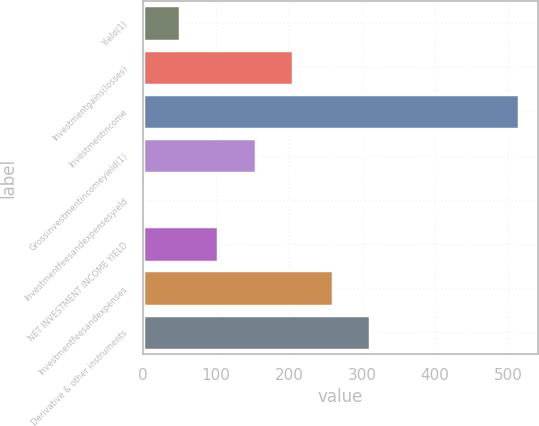Convert chart to OTSL. <chart><loc_0><loc_0><loc_500><loc_500><bar_chart><fcel>Yield(1)<fcel>Investmentgains(losses)<fcel>Investmentincome<fcel>Grossinvestmentincomeyield(1)<fcel>Investmentfeesandexpensesyield<fcel>NET INVESTMENT INCOME YIELD<fcel>Investmentfeesandexpenses<fcel>Derivative & other instruments<nl><fcel>51.63<fcel>206.1<fcel>515<fcel>154.61<fcel>0.14<fcel>103.12<fcel>260<fcel>311.49<nl></chart> 